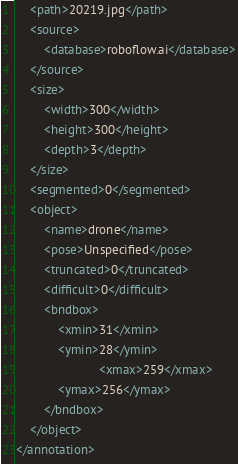Convert code to text. <code><loc_0><loc_0><loc_500><loc_500><_XML_>	<path>20219.jpg</path>
	<source>
		<database>roboflow.ai</database>
	</source>
	<size>
		<width>300</width>
		<height>300</height>
		<depth>3</depth>
	</size>
	<segmented>0</segmented>
	<object>
		<name>drone</name>
		<pose>Unspecified</pose>
		<truncated>0</truncated>
		<difficult>0</difficult>
		<bndbox>
			<xmin>31</xmin>
			<ymin>28</ymin>
                        <xmax>259</xmax>
			<ymax>256</ymax>
		</bndbox>
	</object>
</annotation>
</code> 